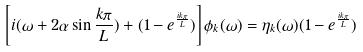<formula> <loc_0><loc_0><loc_500><loc_500>\left [ i ( \omega + 2 \alpha \sin \frac { k \pi } { L } ) + ( 1 - e ^ { \frac { i k \pi } { L } } ) \right ] \phi _ { k } ( \omega ) = \eta _ { k } ( \omega ) ( 1 - e ^ { \frac { i k \pi } { L } } )</formula> 